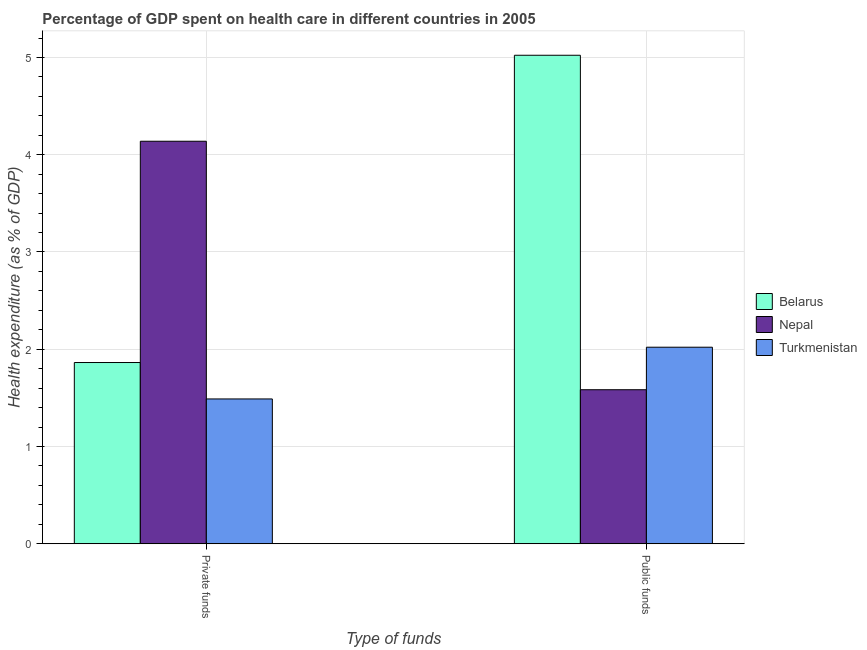How many groups of bars are there?
Give a very brief answer. 2. How many bars are there on the 1st tick from the left?
Provide a succinct answer. 3. How many bars are there on the 1st tick from the right?
Offer a terse response. 3. What is the label of the 2nd group of bars from the left?
Make the answer very short. Public funds. What is the amount of private funds spent in healthcare in Turkmenistan?
Provide a short and direct response. 1.49. Across all countries, what is the maximum amount of private funds spent in healthcare?
Your answer should be very brief. 4.14. Across all countries, what is the minimum amount of private funds spent in healthcare?
Ensure brevity in your answer.  1.49. In which country was the amount of public funds spent in healthcare maximum?
Make the answer very short. Belarus. In which country was the amount of public funds spent in healthcare minimum?
Provide a short and direct response. Nepal. What is the total amount of private funds spent in healthcare in the graph?
Your answer should be very brief. 7.49. What is the difference between the amount of public funds spent in healthcare in Turkmenistan and that in Nepal?
Your answer should be very brief. 0.44. What is the difference between the amount of public funds spent in healthcare in Turkmenistan and the amount of private funds spent in healthcare in Belarus?
Your response must be concise. 0.16. What is the average amount of private funds spent in healthcare per country?
Keep it short and to the point. 2.5. What is the difference between the amount of public funds spent in healthcare and amount of private funds spent in healthcare in Belarus?
Provide a succinct answer. 3.16. What is the ratio of the amount of private funds spent in healthcare in Turkmenistan to that in Nepal?
Your answer should be compact. 0.36. What does the 2nd bar from the left in Public funds represents?
Provide a short and direct response. Nepal. What does the 1st bar from the right in Public funds represents?
Your response must be concise. Turkmenistan. How many bars are there?
Offer a terse response. 6. Are all the bars in the graph horizontal?
Offer a terse response. No. How many countries are there in the graph?
Your response must be concise. 3. Are the values on the major ticks of Y-axis written in scientific E-notation?
Your response must be concise. No. Does the graph contain grids?
Your answer should be very brief. Yes. Where does the legend appear in the graph?
Provide a short and direct response. Center right. How are the legend labels stacked?
Give a very brief answer. Vertical. What is the title of the graph?
Make the answer very short. Percentage of GDP spent on health care in different countries in 2005. Does "Iran" appear as one of the legend labels in the graph?
Provide a short and direct response. No. What is the label or title of the X-axis?
Provide a succinct answer. Type of funds. What is the label or title of the Y-axis?
Provide a succinct answer. Health expenditure (as % of GDP). What is the Health expenditure (as % of GDP) of Belarus in Private funds?
Your answer should be compact. 1.86. What is the Health expenditure (as % of GDP) in Nepal in Private funds?
Keep it short and to the point. 4.14. What is the Health expenditure (as % of GDP) in Turkmenistan in Private funds?
Give a very brief answer. 1.49. What is the Health expenditure (as % of GDP) of Belarus in Public funds?
Keep it short and to the point. 5.02. What is the Health expenditure (as % of GDP) of Nepal in Public funds?
Your answer should be compact. 1.58. What is the Health expenditure (as % of GDP) of Turkmenistan in Public funds?
Your answer should be very brief. 2.02. Across all Type of funds, what is the maximum Health expenditure (as % of GDP) in Belarus?
Ensure brevity in your answer.  5.02. Across all Type of funds, what is the maximum Health expenditure (as % of GDP) in Nepal?
Offer a very short reply. 4.14. Across all Type of funds, what is the maximum Health expenditure (as % of GDP) of Turkmenistan?
Give a very brief answer. 2.02. Across all Type of funds, what is the minimum Health expenditure (as % of GDP) in Belarus?
Provide a succinct answer. 1.86. Across all Type of funds, what is the minimum Health expenditure (as % of GDP) in Nepal?
Make the answer very short. 1.58. Across all Type of funds, what is the minimum Health expenditure (as % of GDP) of Turkmenistan?
Your answer should be compact. 1.49. What is the total Health expenditure (as % of GDP) of Belarus in the graph?
Make the answer very short. 6.89. What is the total Health expenditure (as % of GDP) in Nepal in the graph?
Keep it short and to the point. 5.72. What is the total Health expenditure (as % of GDP) of Turkmenistan in the graph?
Provide a succinct answer. 3.51. What is the difference between the Health expenditure (as % of GDP) in Belarus in Private funds and that in Public funds?
Your response must be concise. -3.16. What is the difference between the Health expenditure (as % of GDP) in Nepal in Private funds and that in Public funds?
Offer a very short reply. 2.55. What is the difference between the Health expenditure (as % of GDP) of Turkmenistan in Private funds and that in Public funds?
Provide a succinct answer. -0.53. What is the difference between the Health expenditure (as % of GDP) in Belarus in Private funds and the Health expenditure (as % of GDP) in Nepal in Public funds?
Give a very brief answer. 0.28. What is the difference between the Health expenditure (as % of GDP) in Belarus in Private funds and the Health expenditure (as % of GDP) in Turkmenistan in Public funds?
Make the answer very short. -0.16. What is the difference between the Health expenditure (as % of GDP) in Nepal in Private funds and the Health expenditure (as % of GDP) in Turkmenistan in Public funds?
Offer a very short reply. 2.12. What is the average Health expenditure (as % of GDP) of Belarus per Type of funds?
Keep it short and to the point. 3.44. What is the average Health expenditure (as % of GDP) in Nepal per Type of funds?
Keep it short and to the point. 2.86. What is the average Health expenditure (as % of GDP) of Turkmenistan per Type of funds?
Provide a succinct answer. 1.76. What is the difference between the Health expenditure (as % of GDP) in Belarus and Health expenditure (as % of GDP) in Nepal in Private funds?
Offer a very short reply. -2.28. What is the difference between the Health expenditure (as % of GDP) in Belarus and Health expenditure (as % of GDP) in Turkmenistan in Private funds?
Give a very brief answer. 0.37. What is the difference between the Health expenditure (as % of GDP) in Nepal and Health expenditure (as % of GDP) in Turkmenistan in Private funds?
Make the answer very short. 2.65. What is the difference between the Health expenditure (as % of GDP) in Belarus and Health expenditure (as % of GDP) in Nepal in Public funds?
Offer a terse response. 3.44. What is the difference between the Health expenditure (as % of GDP) in Belarus and Health expenditure (as % of GDP) in Turkmenistan in Public funds?
Provide a short and direct response. 3. What is the difference between the Health expenditure (as % of GDP) in Nepal and Health expenditure (as % of GDP) in Turkmenistan in Public funds?
Offer a very short reply. -0.44. What is the ratio of the Health expenditure (as % of GDP) in Belarus in Private funds to that in Public funds?
Ensure brevity in your answer.  0.37. What is the ratio of the Health expenditure (as % of GDP) in Nepal in Private funds to that in Public funds?
Provide a short and direct response. 2.61. What is the ratio of the Health expenditure (as % of GDP) of Turkmenistan in Private funds to that in Public funds?
Give a very brief answer. 0.74. What is the difference between the highest and the second highest Health expenditure (as % of GDP) of Belarus?
Provide a succinct answer. 3.16. What is the difference between the highest and the second highest Health expenditure (as % of GDP) of Nepal?
Your answer should be very brief. 2.55. What is the difference between the highest and the second highest Health expenditure (as % of GDP) of Turkmenistan?
Make the answer very short. 0.53. What is the difference between the highest and the lowest Health expenditure (as % of GDP) in Belarus?
Your answer should be compact. 3.16. What is the difference between the highest and the lowest Health expenditure (as % of GDP) of Nepal?
Offer a very short reply. 2.55. What is the difference between the highest and the lowest Health expenditure (as % of GDP) in Turkmenistan?
Provide a succinct answer. 0.53. 